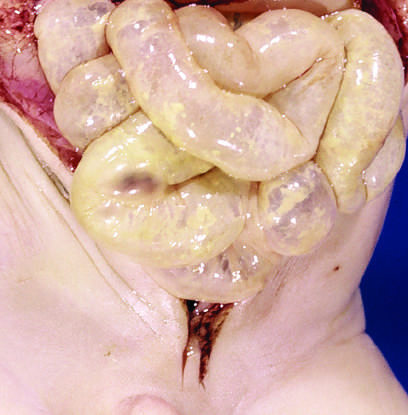does this appearance imply impending perforation?
Answer the question using a single word or phrase. Yes 